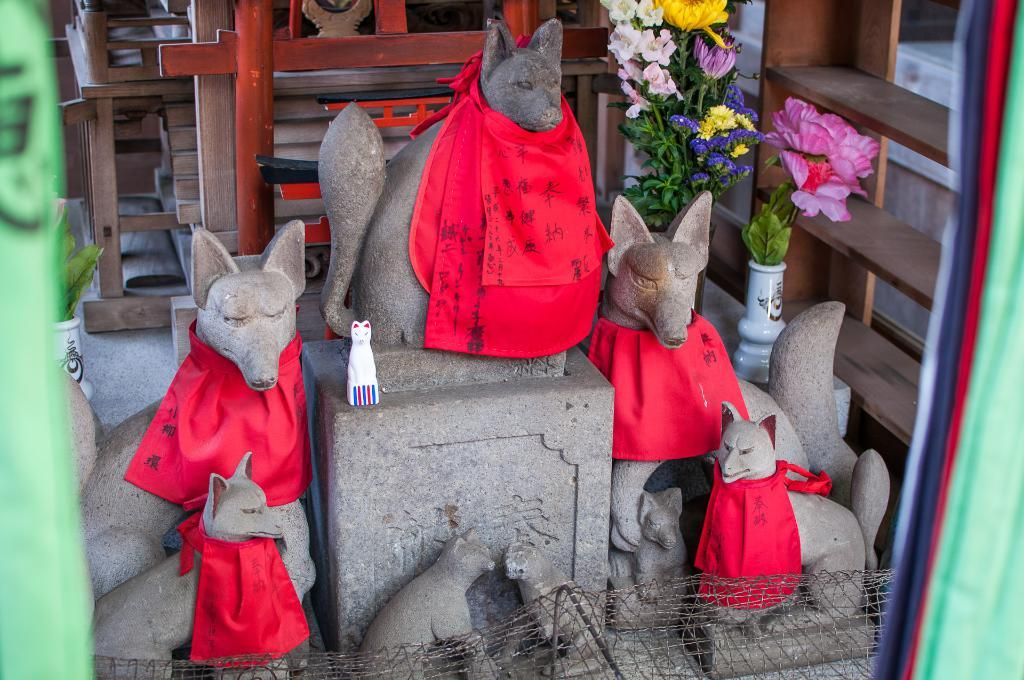What is located in the center of the image? There are sculptures, clothes, vases, and flowers in the center of the image. What type of objects can be seen on the racks in the background? The information provided does not specify the objects on the racks in the background. What type of furniture is visible in the background of the image? There are tables in the background of the image. What other objects can be seen in the background of the image? There are other objects in the background of the image, but their specific details are not mentioned in the provided facts. What type of feeling does the example in the image evoke? There is no example or feeling mentioned in the image; it features sculptures, clothes, vases, and flowers in the center, along with racks, tables, and other objects in the background. 